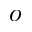<formula> <loc_0><loc_0><loc_500><loc_500>o</formula> 